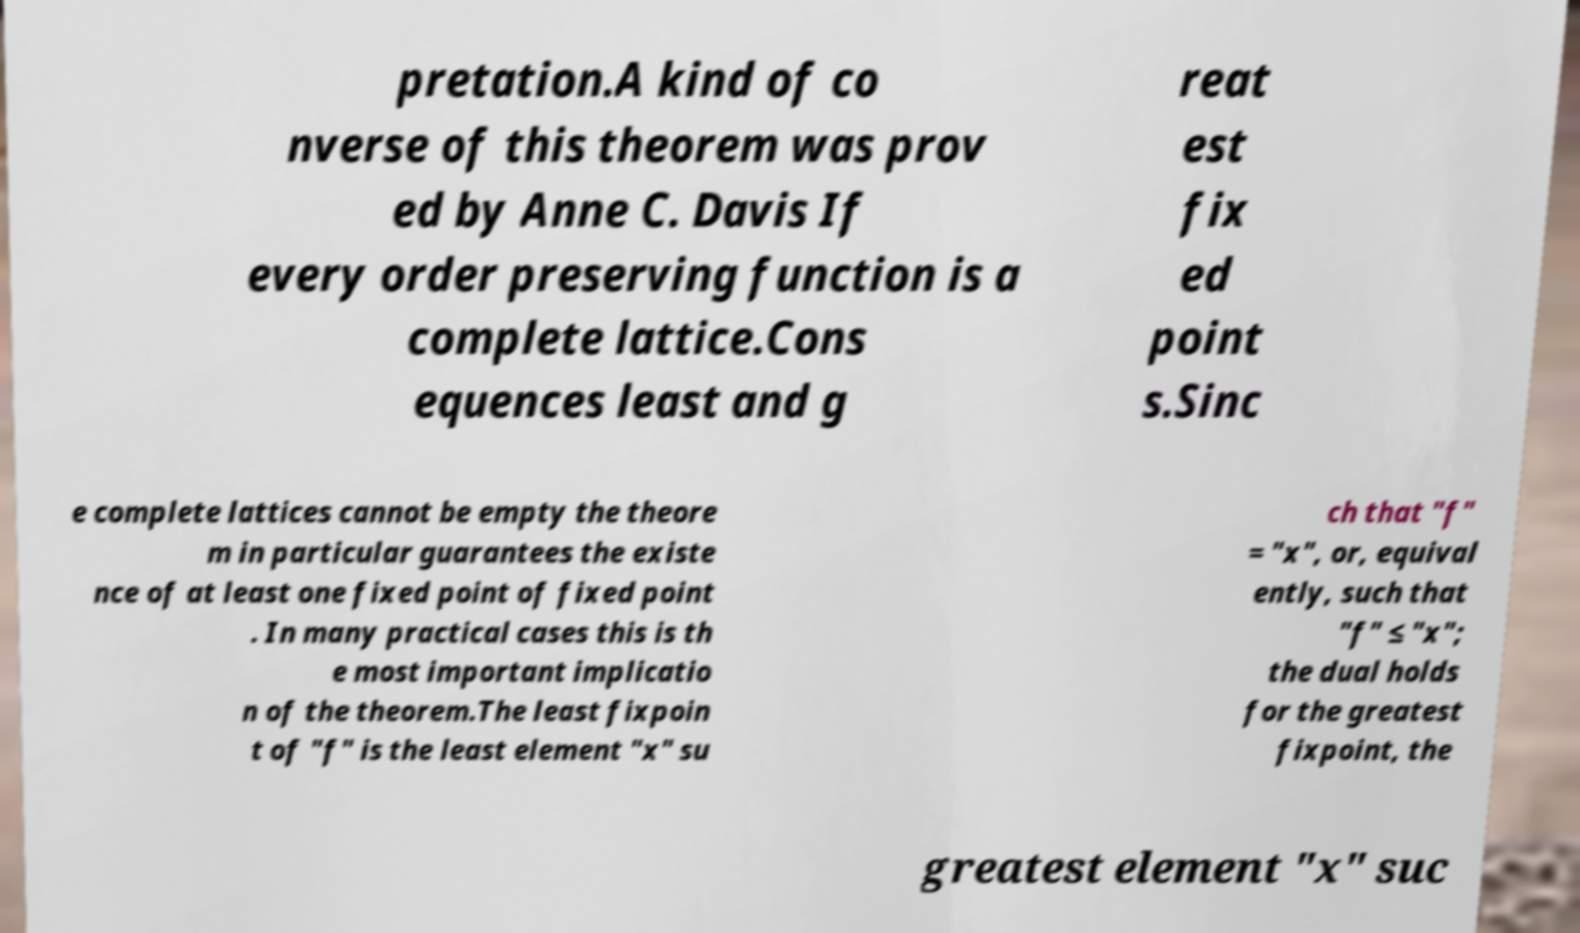Could you assist in decoding the text presented in this image and type it out clearly? pretation.A kind of co nverse of this theorem was prov ed by Anne C. Davis If every order preserving function is a complete lattice.Cons equences least and g reat est fix ed point s.Sinc e complete lattices cannot be empty the theore m in particular guarantees the existe nce of at least one fixed point of fixed point . In many practical cases this is th e most important implicatio n of the theorem.The least fixpoin t of "f" is the least element "x" su ch that "f" = "x", or, equival ently, such that "f" ≤ "x"; the dual holds for the greatest fixpoint, the greatest element "x" suc 